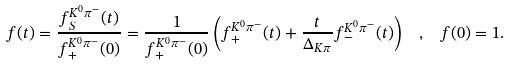Convert formula to latex. <formula><loc_0><loc_0><loc_500><loc_500>f ( t ) = \frac { f ^ { K ^ { 0 } \pi ^ { - } } _ { S } ( t ) } { f ^ { K ^ { 0 } \pi ^ { - } } _ { + } ( 0 ) } = \frac { 1 } { f ^ { K ^ { 0 } \pi ^ { - } } _ { + } ( 0 ) } \left ( f ^ { K ^ { 0 } \pi ^ { - } } _ { + } ( t ) + \frac { t } { \Delta _ { K \pi } } f ^ { K ^ { 0 } \pi ^ { - } } _ { - } ( t ) \right ) \ \ , \ \ f ( 0 ) = 1 .</formula> 